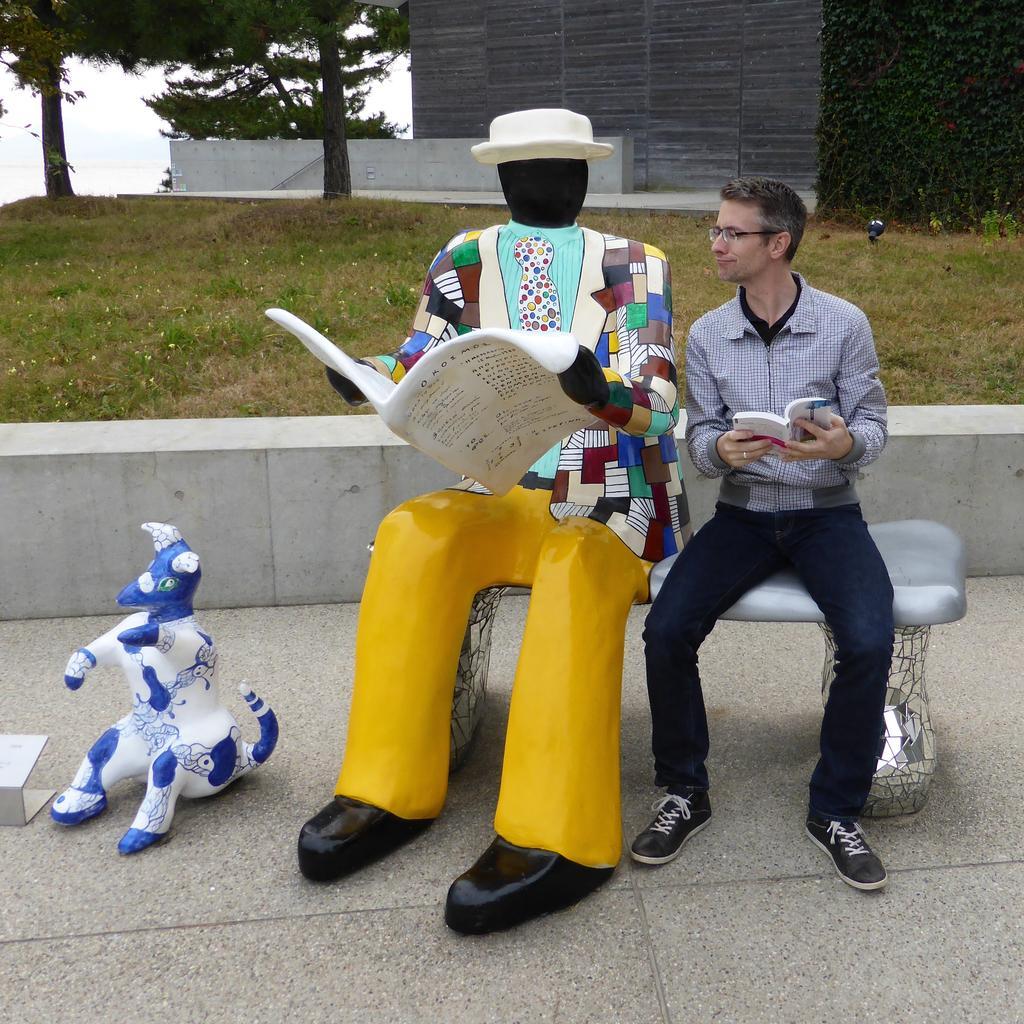Please provide a concise description of this image. In this image there is a statue of a person holding book and sat on the bench, beside the statue there is a person holding book and looking to the statue. On the left side of the image there is a toy placed on the ground, behind them there is a grass, trees and a building. 